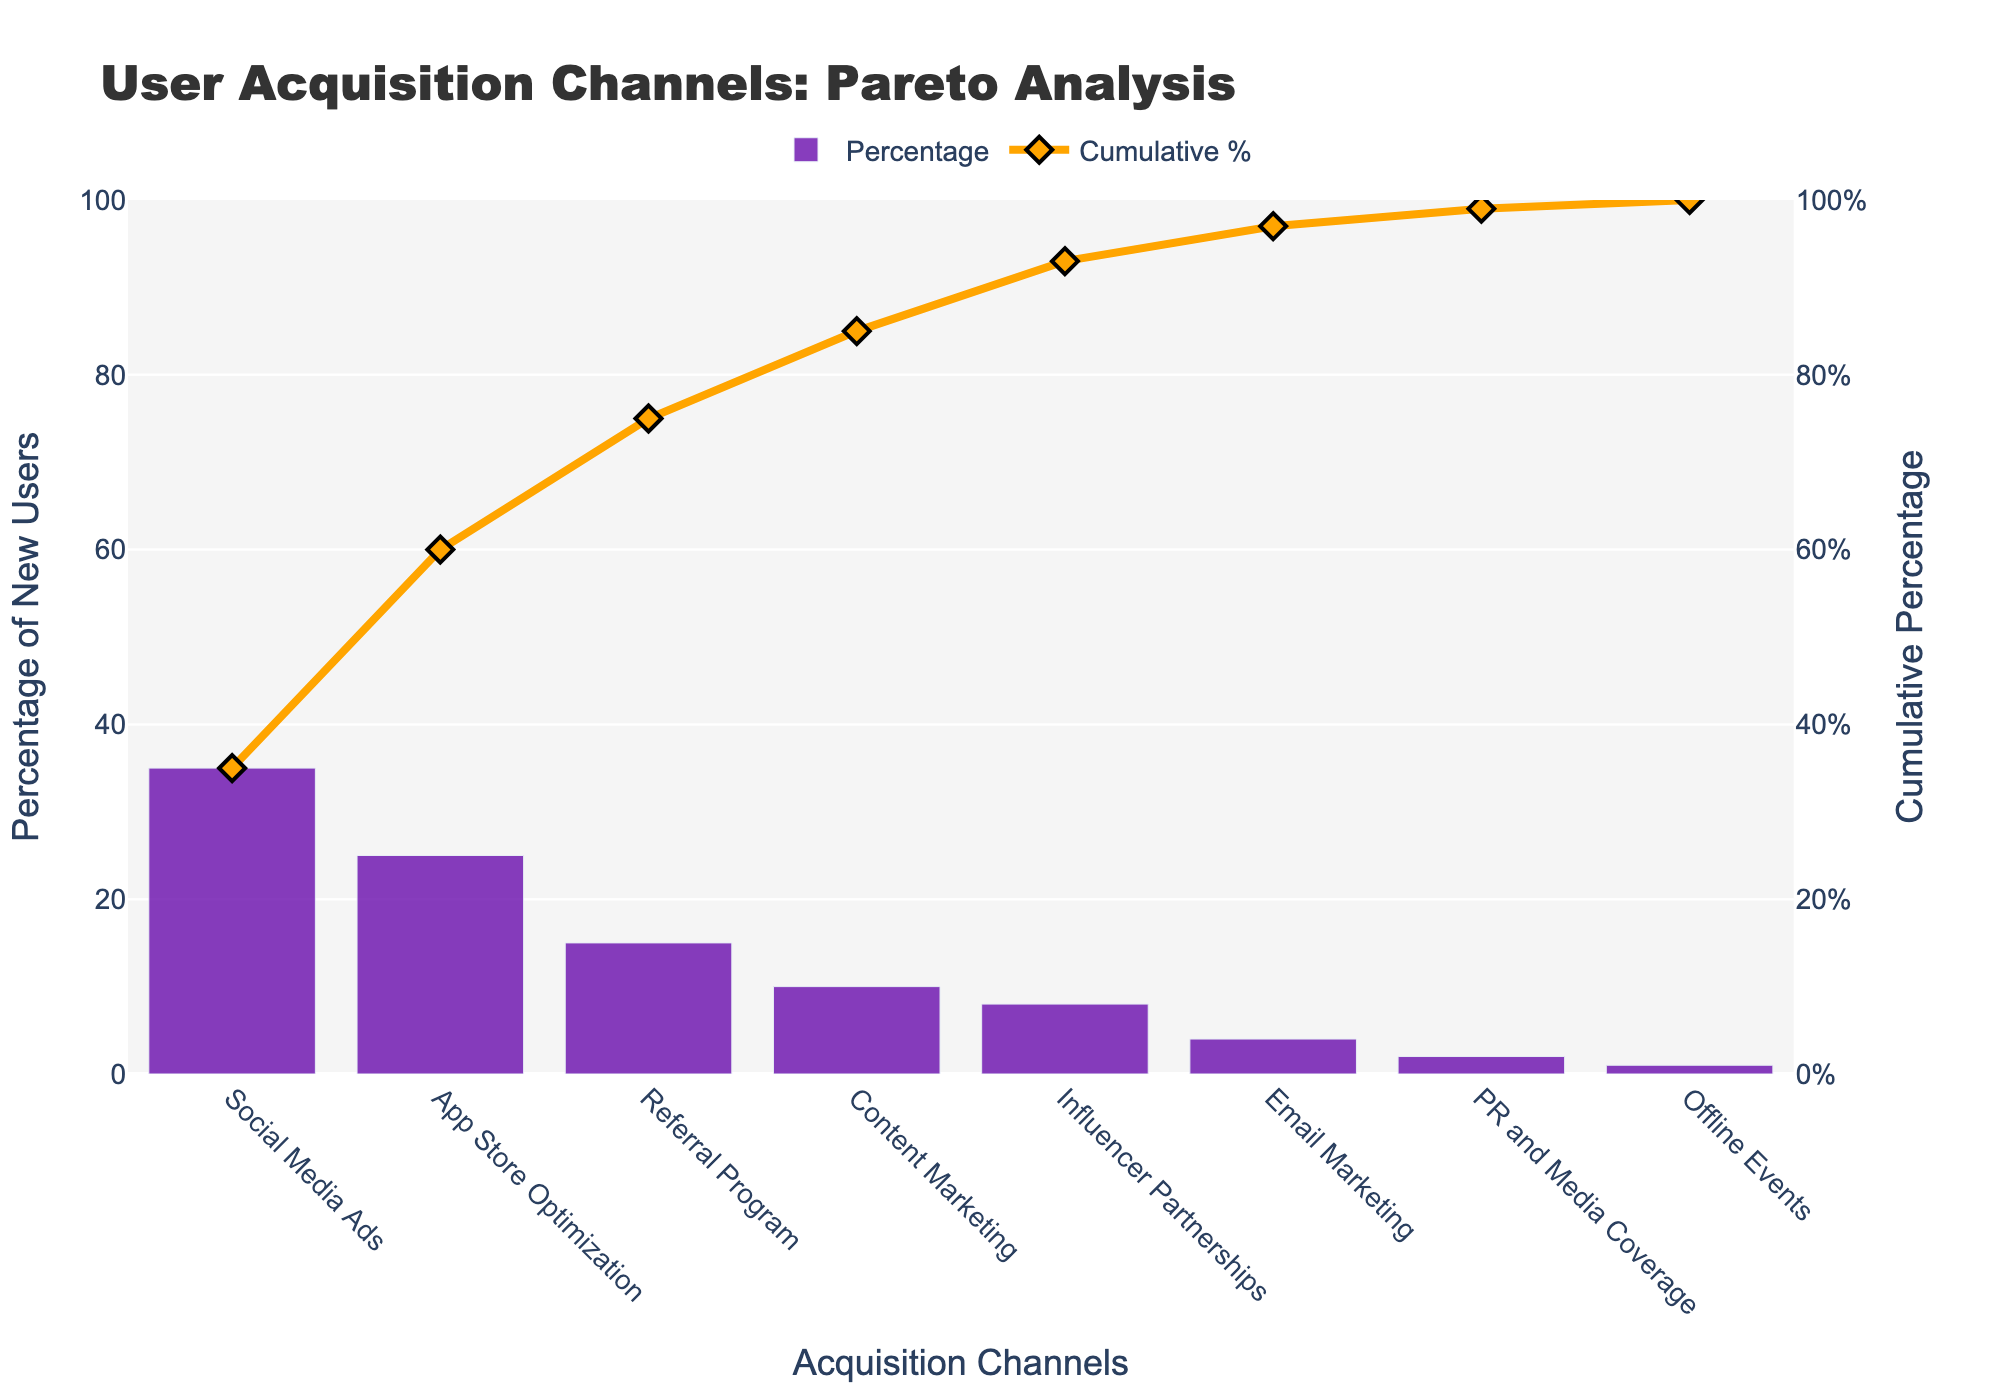What's the title of the chart? The title is prominently displayed at the top of the chart.
Answer: User Acquisition Channels: Pareto Analysis Which channel brings in the highest percentage of new users? The tallest bar on the bar chart indicates the channel with the highest percentage.
Answer: Social Media Ads What is the cumulative percentage of new users by the top two channels? Add the percentage contributions of Social Media Ads (35%) and App Store Optimization (25%). 35% + 25% = 60%
Answer: 60% What is the cumulative percentage after the first four channels? Cumulatively add the first four percentages: 35% (Social Media Ads) + 25% (App Store Optimization) + 15% (Referral Program) + 10% (Content Marketing). 35% + 25% + 15% + 10% = 85%
Answer: 85% Which channel contributes less than 5% to new users? Bars with percentages less than 5% are Email Marketing (4%), PR and Media Coverage (2%), and Offline Events (1%).
Answer: Email Marketing, PR and Media Coverage, Offline Events How does the percentage from Influencer Partnerships compare to Email Marketing? Influencer Partnerships has an 8% contribution, higher than Email Marketing which has a 4% contribution.
Answer: Higher What percentage of new users comes from the Referral Program channel? The bar labeled "Referral Program" shows a height indicating 15%.
Answer: 15% Which channels together account for more than 50% of new users? Add the percentages starting from the highest until the total exceeds 50%: Social Media Ads (35%) + App Store Optimization (25%). 35% + 25% = 60%
Answer: Social Media Ads and App Store Optimization What is the difference in percentage contribution between the top channel and the second top channel? Subtract the percentage of App Store Optimization (25%) from Social Media Ads (35%). 35% - 25% = 10%
Answer: 10% How many channels contribute to the cumulative percentage reaching 90%? Adding the percentages until the cumulative sum is 90%: Social Media Ads (35%), App Store Optimization (25%), Referral Program (15%), Content Marketing (10%), Influencer Partnerships (8%). 35% + 25% + 15% + 10% + 8% = 93%.
Answer: 5 channels 